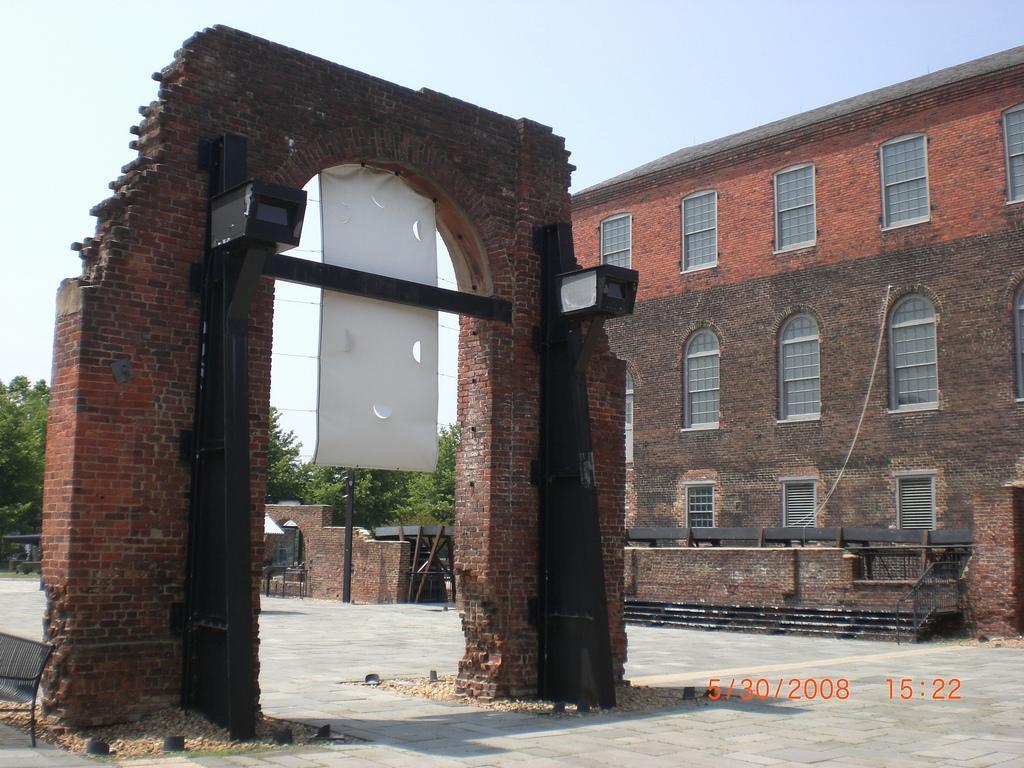Please provide a concise description of this image. In this picture we can see arch, poles, banner, walls, ground, chair and objects. In the background of the image we can see buildings, windows, trees and sky. 